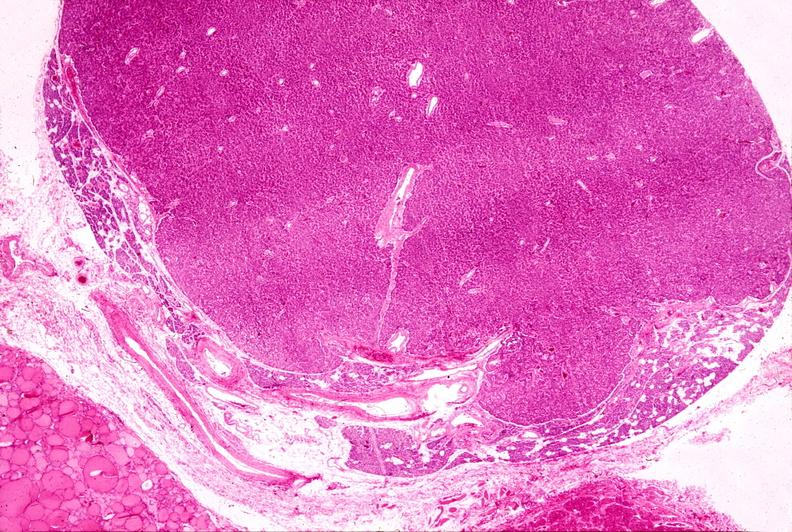what does this image show?
Answer the question using a single word or phrase. Parathyroid adenoma 